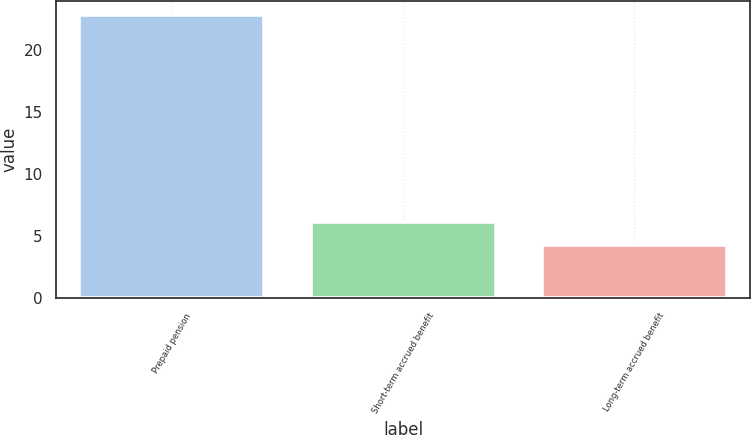Convert chart. <chart><loc_0><loc_0><loc_500><loc_500><bar_chart><fcel>Prepaid pension<fcel>Short-term accrued benefit<fcel>Long-term accrued benefit<nl><fcel>22.8<fcel>6.15<fcel>4.3<nl></chart> 